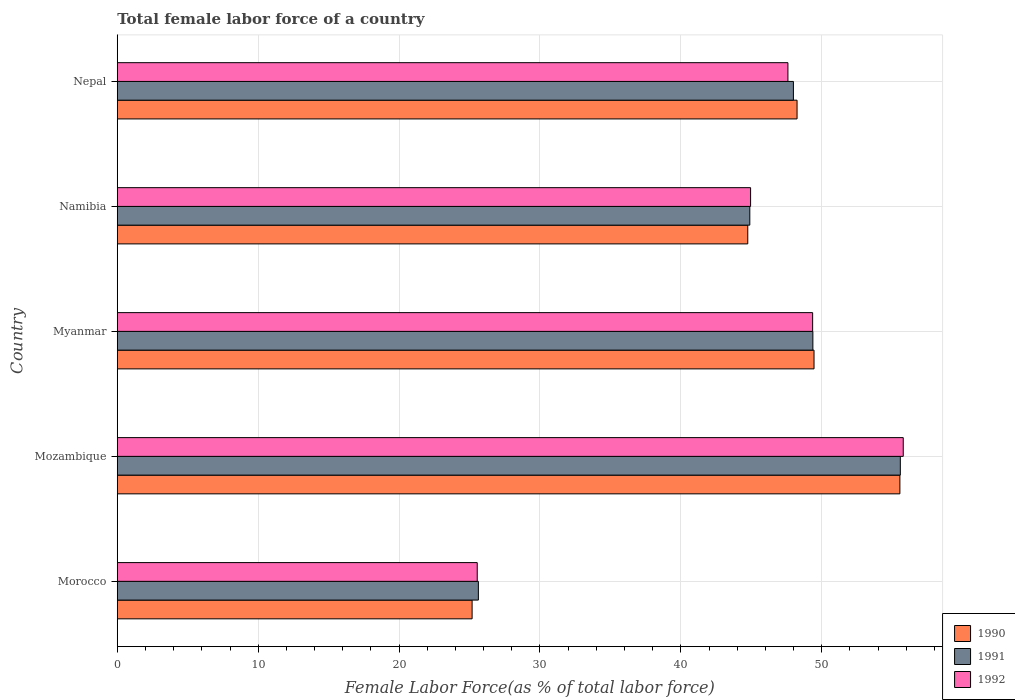Are the number of bars per tick equal to the number of legend labels?
Your response must be concise. Yes. How many bars are there on the 3rd tick from the top?
Your answer should be very brief. 3. What is the label of the 4th group of bars from the top?
Give a very brief answer. Mozambique. In how many cases, is the number of bars for a given country not equal to the number of legend labels?
Give a very brief answer. 0. What is the percentage of female labor force in 1992 in Nepal?
Provide a succinct answer. 47.6. Across all countries, what is the maximum percentage of female labor force in 1992?
Make the answer very short. 55.78. Across all countries, what is the minimum percentage of female labor force in 1992?
Provide a short and direct response. 25.55. In which country was the percentage of female labor force in 1991 maximum?
Offer a very short reply. Mozambique. In which country was the percentage of female labor force in 1992 minimum?
Your response must be concise. Morocco. What is the total percentage of female labor force in 1991 in the graph?
Provide a succinct answer. 223.44. What is the difference between the percentage of female labor force in 1992 in Mozambique and that in Myanmar?
Provide a succinct answer. 6.43. What is the difference between the percentage of female labor force in 1992 in Myanmar and the percentage of female labor force in 1990 in Mozambique?
Your answer should be compact. -6.19. What is the average percentage of female labor force in 1990 per country?
Give a very brief answer. 44.63. What is the difference between the percentage of female labor force in 1991 and percentage of female labor force in 1992 in Myanmar?
Give a very brief answer. 0.02. What is the ratio of the percentage of female labor force in 1992 in Mozambique to that in Namibia?
Ensure brevity in your answer.  1.24. Is the percentage of female labor force in 1991 in Namibia less than that in Nepal?
Provide a succinct answer. Yes. What is the difference between the highest and the second highest percentage of female labor force in 1990?
Offer a terse response. 6.09. What is the difference between the highest and the lowest percentage of female labor force in 1991?
Give a very brief answer. 29.95. Is the sum of the percentage of female labor force in 1990 in Morocco and Mozambique greater than the maximum percentage of female labor force in 1991 across all countries?
Give a very brief answer. Yes. What does the 3rd bar from the top in Namibia represents?
Your response must be concise. 1990. Is it the case that in every country, the sum of the percentage of female labor force in 1991 and percentage of female labor force in 1992 is greater than the percentage of female labor force in 1990?
Offer a very short reply. Yes. What is the difference between two consecutive major ticks on the X-axis?
Your answer should be compact. 10. Are the values on the major ticks of X-axis written in scientific E-notation?
Make the answer very short. No. Does the graph contain any zero values?
Ensure brevity in your answer.  No. Where does the legend appear in the graph?
Make the answer very short. Bottom right. How are the legend labels stacked?
Offer a terse response. Vertical. What is the title of the graph?
Keep it short and to the point. Total female labor force of a country. Does "1973" appear as one of the legend labels in the graph?
Your answer should be very brief. No. What is the label or title of the X-axis?
Offer a terse response. Female Labor Force(as % of total labor force). What is the label or title of the Y-axis?
Your answer should be very brief. Country. What is the Female Labor Force(as % of total labor force) in 1990 in Morocco?
Your answer should be compact. 25.18. What is the Female Labor Force(as % of total labor force) of 1991 in Morocco?
Your answer should be very brief. 25.63. What is the Female Labor Force(as % of total labor force) in 1992 in Morocco?
Provide a succinct answer. 25.55. What is the Female Labor Force(as % of total labor force) of 1990 in Mozambique?
Provide a short and direct response. 55.54. What is the Female Labor Force(as % of total labor force) of 1991 in Mozambique?
Your answer should be compact. 55.57. What is the Female Labor Force(as % of total labor force) of 1992 in Mozambique?
Your response must be concise. 55.78. What is the Female Labor Force(as % of total labor force) of 1990 in Myanmar?
Your answer should be very brief. 49.45. What is the Female Labor Force(as % of total labor force) in 1991 in Myanmar?
Offer a very short reply. 49.37. What is the Female Labor Force(as % of total labor force) of 1992 in Myanmar?
Your answer should be very brief. 49.35. What is the Female Labor Force(as % of total labor force) in 1990 in Namibia?
Provide a short and direct response. 44.75. What is the Female Labor Force(as % of total labor force) in 1991 in Namibia?
Give a very brief answer. 44.89. What is the Female Labor Force(as % of total labor force) in 1992 in Namibia?
Your answer should be compact. 44.95. What is the Female Labor Force(as % of total labor force) of 1990 in Nepal?
Offer a terse response. 48.24. What is the Female Labor Force(as % of total labor force) of 1991 in Nepal?
Your response must be concise. 47.99. What is the Female Labor Force(as % of total labor force) in 1992 in Nepal?
Offer a very short reply. 47.6. Across all countries, what is the maximum Female Labor Force(as % of total labor force) in 1990?
Ensure brevity in your answer.  55.54. Across all countries, what is the maximum Female Labor Force(as % of total labor force) in 1991?
Keep it short and to the point. 55.57. Across all countries, what is the maximum Female Labor Force(as % of total labor force) in 1992?
Provide a short and direct response. 55.78. Across all countries, what is the minimum Female Labor Force(as % of total labor force) of 1990?
Ensure brevity in your answer.  25.18. Across all countries, what is the minimum Female Labor Force(as % of total labor force) in 1991?
Provide a short and direct response. 25.63. Across all countries, what is the minimum Female Labor Force(as % of total labor force) in 1992?
Your answer should be compact. 25.55. What is the total Female Labor Force(as % of total labor force) in 1990 in the graph?
Your answer should be very brief. 223.16. What is the total Female Labor Force(as % of total labor force) of 1991 in the graph?
Offer a terse response. 223.44. What is the total Female Labor Force(as % of total labor force) of 1992 in the graph?
Offer a very short reply. 223.22. What is the difference between the Female Labor Force(as % of total labor force) in 1990 in Morocco and that in Mozambique?
Provide a succinct answer. -30.36. What is the difference between the Female Labor Force(as % of total labor force) of 1991 in Morocco and that in Mozambique?
Keep it short and to the point. -29.95. What is the difference between the Female Labor Force(as % of total labor force) in 1992 in Morocco and that in Mozambique?
Give a very brief answer. -30.24. What is the difference between the Female Labor Force(as % of total labor force) in 1990 in Morocco and that in Myanmar?
Keep it short and to the point. -24.27. What is the difference between the Female Labor Force(as % of total labor force) in 1991 in Morocco and that in Myanmar?
Keep it short and to the point. -23.74. What is the difference between the Female Labor Force(as % of total labor force) of 1992 in Morocco and that in Myanmar?
Your answer should be compact. -23.8. What is the difference between the Female Labor Force(as % of total labor force) in 1990 in Morocco and that in Namibia?
Your response must be concise. -19.56. What is the difference between the Female Labor Force(as % of total labor force) of 1991 in Morocco and that in Namibia?
Make the answer very short. -19.26. What is the difference between the Female Labor Force(as % of total labor force) of 1992 in Morocco and that in Namibia?
Ensure brevity in your answer.  -19.4. What is the difference between the Female Labor Force(as % of total labor force) of 1990 in Morocco and that in Nepal?
Ensure brevity in your answer.  -23.06. What is the difference between the Female Labor Force(as % of total labor force) of 1991 in Morocco and that in Nepal?
Your answer should be compact. -22.36. What is the difference between the Female Labor Force(as % of total labor force) in 1992 in Morocco and that in Nepal?
Offer a terse response. -22.05. What is the difference between the Female Labor Force(as % of total labor force) in 1990 in Mozambique and that in Myanmar?
Ensure brevity in your answer.  6.09. What is the difference between the Female Labor Force(as % of total labor force) in 1991 in Mozambique and that in Myanmar?
Your answer should be very brief. 6.21. What is the difference between the Female Labor Force(as % of total labor force) in 1992 in Mozambique and that in Myanmar?
Ensure brevity in your answer.  6.43. What is the difference between the Female Labor Force(as % of total labor force) in 1990 in Mozambique and that in Namibia?
Offer a very short reply. 10.8. What is the difference between the Female Labor Force(as % of total labor force) in 1991 in Mozambique and that in Namibia?
Ensure brevity in your answer.  10.68. What is the difference between the Female Labor Force(as % of total labor force) of 1992 in Mozambique and that in Namibia?
Your answer should be compact. 10.83. What is the difference between the Female Labor Force(as % of total labor force) of 1990 in Mozambique and that in Nepal?
Provide a short and direct response. 7.3. What is the difference between the Female Labor Force(as % of total labor force) in 1991 in Mozambique and that in Nepal?
Make the answer very short. 7.59. What is the difference between the Female Labor Force(as % of total labor force) of 1992 in Mozambique and that in Nepal?
Keep it short and to the point. 8.19. What is the difference between the Female Labor Force(as % of total labor force) in 1990 in Myanmar and that in Namibia?
Your answer should be very brief. 4.7. What is the difference between the Female Labor Force(as % of total labor force) in 1991 in Myanmar and that in Namibia?
Provide a succinct answer. 4.48. What is the difference between the Female Labor Force(as % of total labor force) of 1992 in Myanmar and that in Namibia?
Your answer should be very brief. 4.4. What is the difference between the Female Labor Force(as % of total labor force) in 1990 in Myanmar and that in Nepal?
Give a very brief answer. 1.2. What is the difference between the Female Labor Force(as % of total labor force) in 1991 in Myanmar and that in Nepal?
Make the answer very short. 1.38. What is the difference between the Female Labor Force(as % of total labor force) in 1992 in Myanmar and that in Nepal?
Make the answer very short. 1.75. What is the difference between the Female Labor Force(as % of total labor force) in 1990 in Namibia and that in Nepal?
Provide a short and direct response. -3.5. What is the difference between the Female Labor Force(as % of total labor force) of 1991 in Namibia and that in Nepal?
Provide a succinct answer. -3.09. What is the difference between the Female Labor Force(as % of total labor force) in 1992 in Namibia and that in Nepal?
Keep it short and to the point. -2.65. What is the difference between the Female Labor Force(as % of total labor force) in 1990 in Morocco and the Female Labor Force(as % of total labor force) in 1991 in Mozambique?
Offer a very short reply. -30.39. What is the difference between the Female Labor Force(as % of total labor force) in 1990 in Morocco and the Female Labor Force(as % of total labor force) in 1992 in Mozambique?
Make the answer very short. -30.6. What is the difference between the Female Labor Force(as % of total labor force) in 1991 in Morocco and the Female Labor Force(as % of total labor force) in 1992 in Mozambique?
Your answer should be compact. -30.15. What is the difference between the Female Labor Force(as % of total labor force) in 1990 in Morocco and the Female Labor Force(as % of total labor force) in 1991 in Myanmar?
Your answer should be very brief. -24.18. What is the difference between the Female Labor Force(as % of total labor force) of 1990 in Morocco and the Female Labor Force(as % of total labor force) of 1992 in Myanmar?
Provide a short and direct response. -24.17. What is the difference between the Female Labor Force(as % of total labor force) of 1991 in Morocco and the Female Labor Force(as % of total labor force) of 1992 in Myanmar?
Give a very brief answer. -23.72. What is the difference between the Female Labor Force(as % of total labor force) of 1990 in Morocco and the Female Labor Force(as % of total labor force) of 1991 in Namibia?
Keep it short and to the point. -19.71. What is the difference between the Female Labor Force(as % of total labor force) in 1990 in Morocco and the Female Labor Force(as % of total labor force) in 1992 in Namibia?
Offer a very short reply. -19.76. What is the difference between the Female Labor Force(as % of total labor force) of 1991 in Morocco and the Female Labor Force(as % of total labor force) of 1992 in Namibia?
Your response must be concise. -19.32. What is the difference between the Female Labor Force(as % of total labor force) in 1990 in Morocco and the Female Labor Force(as % of total labor force) in 1991 in Nepal?
Give a very brief answer. -22.8. What is the difference between the Female Labor Force(as % of total labor force) in 1990 in Morocco and the Female Labor Force(as % of total labor force) in 1992 in Nepal?
Ensure brevity in your answer.  -22.41. What is the difference between the Female Labor Force(as % of total labor force) of 1991 in Morocco and the Female Labor Force(as % of total labor force) of 1992 in Nepal?
Provide a succinct answer. -21.97. What is the difference between the Female Labor Force(as % of total labor force) of 1990 in Mozambique and the Female Labor Force(as % of total labor force) of 1991 in Myanmar?
Your answer should be very brief. 6.18. What is the difference between the Female Labor Force(as % of total labor force) in 1990 in Mozambique and the Female Labor Force(as % of total labor force) in 1992 in Myanmar?
Keep it short and to the point. 6.19. What is the difference between the Female Labor Force(as % of total labor force) in 1991 in Mozambique and the Female Labor Force(as % of total labor force) in 1992 in Myanmar?
Make the answer very short. 6.22. What is the difference between the Female Labor Force(as % of total labor force) of 1990 in Mozambique and the Female Labor Force(as % of total labor force) of 1991 in Namibia?
Your response must be concise. 10.65. What is the difference between the Female Labor Force(as % of total labor force) of 1990 in Mozambique and the Female Labor Force(as % of total labor force) of 1992 in Namibia?
Your answer should be compact. 10.6. What is the difference between the Female Labor Force(as % of total labor force) of 1991 in Mozambique and the Female Labor Force(as % of total labor force) of 1992 in Namibia?
Offer a terse response. 10.63. What is the difference between the Female Labor Force(as % of total labor force) in 1990 in Mozambique and the Female Labor Force(as % of total labor force) in 1991 in Nepal?
Make the answer very short. 7.56. What is the difference between the Female Labor Force(as % of total labor force) of 1990 in Mozambique and the Female Labor Force(as % of total labor force) of 1992 in Nepal?
Give a very brief answer. 7.95. What is the difference between the Female Labor Force(as % of total labor force) in 1991 in Mozambique and the Female Labor Force(as % of total labor force) in 1992 in Nepal?
Ensure brevity in your answer.  7.98. What is the difference between the Female Labor Force(as % of total labor force) of 1990 in Myanmar and the Female Labor Force(as % of total labor force) of 1991 in Namibia?
Offer a terse response. 4.56. What is the difference between the Female Labor Force(as % of total labor force) of 1990 in Myanmar and the Female Labor Force(as % of total labor force) of 1992 in Namibia?
Ensure brevity in your answer.  4.5. What is the difference between the Female Labor Force(as % of total labor force) in 1991 in Myanmar and the Female Labor Force(as % of total labor force) in 1992 in Namibia?
Offer a very short reply. 4.42. What is the difference between the Female Labor Force(as % of total labor force) in 1990 in Myanmar and the Female Labor Force(as % of total labor force) in 1991 in Nepal?
Your response must be concise. 1.46. What is the difference between the Female Labor Force(as % of total labor force) in 1990 in Myanmar and the Female Labor Force(as % of total labor force) in 1992 in Nepal?
Your answer should be very brief. 1.85. What is the difference between the Female Labor Force(as % of total labor force) of 1991 in Myanmar and the Female Labor Force(as % of total labor force) of 1992 in Nepal?
Give a very brief answer. 1.77. What is the difference between the Female Labor Force(as % of total labor force) of 1990 in Namibia and the Female Labor Force(as % of total labor force) of 1991 in Nepal?
Offer a very short reply. -3.24. What is the difference between the Female Labor Force(as % of total labor force) of 1990 in Namibia and the Female Labor Force(as % of total labor force) of 1992 in Nepal?
Ensure brevity in your answer.  -2.85. What is the difference between the Female Labor Force(as % of total labor force) in 1991 in Namibia and the Female Labor Force(as % of total labor force) in 1992 in Nepal?
Offer a very short reply. -2.71. What is the average Female Labor Force(as % of total labor force) in 1990 per country?
Keep it short and to the point. 44.63. What is the average Female Labor Force(as % of total labor force) in 1991 per country?
Offer a terse response. 44.69. What is the average Female Labor Force(as % of total labor force) of 1992 per country?
Make the answer very short. 44.64. What is the difference between the Female Labor Force(as % of total labor force) in 1990 and Female Labor Force(as % of total labor force) in 1991 in Morocco?
Make the answer very short. -0.44. What is the difference between the Female Labor Force(as % of total labor force) in 1990 and Female Labor Force(as % of total labor force) in 1992 in Morocco?
Your answer should be compact. -0.36. What is the difference between the Female Labor Force(as % of total labor force) in 1991 and Female Labor Force(as % of total labor force) in 1992 in Morocco?
Provide a succinct answer. 0.08. What is the difference between the Female Labor Force(as % of total labor force) of 1990 and Female Labor Force(as % of total labor force) of 1991 in Mozambique?
Your answer should be compact. -0.03. What is the difference between the Female Labor Force(as % of total labor force) in 1990 and Female Labor Force(as % of total labor force) in 1992 in Mozambique?
Your response must be concise. -0.24. What is the difference between the Female Labor Force(as % of total labor force) in 1991 and Female Labor Force(as % of total labor force) in 1992 in Mozambique?
Ensure brevity in your answer.  -0.21. What is the difference between the Female Labor Force(as % of total labor force) in 1990 and Female Labor Force(as % of total labor force) in 1991 in Myanmar?
Ensure brevity in your answer.  0.08. What is the difference between the Female Labor Force(as % of total labor force) in 1990 and Female Labor Force(as % of total labor force) in 1992 in Myanmar?
Your answer should be compact. 0.1. What is the difference between the Female Labor Force(as % of total labor force) of 1991 and Female Labor Force(as % of total labor force) of 1992 in Myanmar?
Your answer should be very brief. 0.02. What is the difference between the Female Labor Force(as % of total labor force) of 1990 and Female Labor Force(as % of total labor force) of 1991 in Namibia?
Offer a terse response. -0.15. What is the difference between the Female Labor Force(as % of total labor force) in 1990 and Female Labor Force(as % of total labor force) in 1992 in Namibia?
Make the answer very short. -0.2. What is the difference between the Female Labor Force(as % of total labor force) of 1991 and Female Labor Force(as % of total labor force) of 1992 in Namibia?
Keep it short and to the point. -0.06. What is the difference between the Female Labor Force(as % of total labor force) in 1990 and Female Labor Force(as % of total labor force) in 1991 in Nepal?
Ensure brevity in your answer.  0.26. What is the difference between the Female Labor Force(as % of total labor force) in 1990 and Female Labor Force(as % of total labor force) in 1992 in Nepal?
Offer a terse response. 0.65. What is the difference between the Female Labor Force(as % of total labor force) of 1991 and Female Labor Force(as % of total labor force) of 1992 in Nepal?
Provide a short and direct response. 0.39. What is the ratio of the Female Labor Force(as % of total labor force) in 1990 in Morocco to that in Mozambique?
Provide a succinct answer. 0.45. What is the ratio of the Female Labor Force(as % of total labor force) of 1991 in Morocco to that in Mozambique?
Offer a very short reply. 0.46. What is the ratio of the Female Labor Force(as % of total labor force) of 1992 in Morocco to that in Mozambique?
Your answer should be compact. 0.46. What is the ratio of the Female Labor Force(as % of total labor force) of 1990 in Morocco to that in Myanmar?
Ensure brevity in your answer.  0.51. What is the ratio of the Female Labor Force(as % of total labor force) in 1991 in Morocco to that in Myanmar?
Keep it short and to the point. 0.52. What is the ratio of the Female Labor Force(as % of total labor force) of 1992 in Morocco to that in Myanmar?
Provide a succinct answer. 0.52. What is the ratio of the Female Labor Force(as % of total labor force) in 1990 in Morocco to that in Namibia?
Ensure brevity in your answer.  0.56. What is the ratio of the Female Labor Force(as % of total labor force) in 1991 in Morocco to that in Namibia?
Offer a very short reply. 0.57. What is the ratio of the Female Labor Force(as % of total labor force) in 1992 in Morocco to that in Namibia?
Your response must be concise. 0.57. What is the ratio of the Female Labor Force(as % of total labor force) in 1990 in Morocco to that in Nepal?
Keep it short and to the point. 0.52. What is the ratio of the Female Labor Force(as % of total labor force) in 1991 in Morocco to that in Nepal?
Ensure brevity in your answer.  0.53. What is the ratio of the Female Labor Force(as % of total labor force) of 1992 in Morocco to that in Nepal?
Make the answer very short. 0.54. What is the ratio of the Female Labor Force(as % of total labor force) of 1990 in Mozambique to that in Myanmar?
Keep it short and to the point. 1.12. What is the ratio of the Female Labor Force(as % of total labor force) in 1991 in Mozambique to that in Myanmar?
Provide a short and direct response. 1.13. What is the ratio of the Female Labor Force(as % of total labor force) of 1992 in Mozambique to that in Myanmar?
Provide a short and direct response. 1.13. What is the ratio of the Female Labor Force(as % of total labor force) in 1990 in Mozambique to that in Namibia?
Provide a succinct answer. 1.24. What is the ratio of the Female Labor Force(as % of total labor force) of 1991 in Mozambique to that in Namibia?
Give a very brief answer. 1.24. What is the ratio of the Female Labor Force(as % of total labor force) of 1992 in Mozambique to that in Namibia?
Your answer should be compact. 1.24. What is the ratio of the Female Labor Force(as % of total labor force) in 1990 in Mozambique to that in Nepal?
Give a very brief answer. 1.15. What is the ratio of the Female Labor Force(as % of total labor force) of 1991 in Mozambique to that in Nepal?
Provide a short and direct response. 1.16. What is the ratio of the Female Labor Force(as % of total labor force) in 1992 in Mozambique to that in Nepal?
Your answer should be compact. 1.17. What is the ratio of the Female Labor Force(as % of total labor force) of 1990 in Myanmar to that in Namibia?
Provide a short and direct response. 1.11. What is the ratio of the Female Labor Force(as % of total labor force) in 1991 in Myanmar to that in Namibia?
Your answer should be compact. 1.1. What is the ratio of the Female Labor Force(as % of total labor force) in 1992 in Myanmar to that in Namibia?
Your answer should be compact. 1.1. What is the ratio of the Female Labor Force(as % of total labor force) in 1990 in Myanmar to that in Nepal?
Your answer should be very brief. 1.02. What is the ratio of the Female Labor Force(as % of total labor force) in 1991 in Myanmar to that in Nepal?
Make the answer very short. 1.03. What is the ratio of the Female Labor Force(as % of total labor force) in 1992 in Myanmar to that in Nepal?
Keep it short and to the point. 1.04. What is the ratio of the Female Labor Force(as % of total labor force) of 1990 in Namibia to that in Nepal?
Your response must be concise. 0.93. What is the ratio of the Female Labor Force(as % of total labor force) in 1991 in Namibia to that in Nepal?
Your answer should be very brief. 0.94. What is the ratio of the Female Labor Force(as % of total labor force) in 1992 in Namibia to that in Nepal?
Provide a succinct answer. 0.94. What is the difference between the highest and the second highest Female Labor Force(as % of total labor force) of 1990?
Ensure brevity in your answer.  6.09. What is the difference between the highest and the second highest Female Labor Force(as % of total labor force) of 1991?
Offer a terse response. 6.21. What is the difference between the highest and the second highest Female Labor Force(as % of total labor force) of 1992?
Your response must be concise. 6.43. What is the difference between the highest and the lowest Female Labor Force(as % of total labor force) of 1990?
Keep it short and to the point. 30.36. What is the difference between the highest and the lowest Female Labor Force(as % of total labor force) in 1991?
Provide a succinct answer. 29.95. What is the difference between the highest and the lowest Female Labor Force(as % of total labor force) in 1992?
Your answer should be very brief. 30.24. 